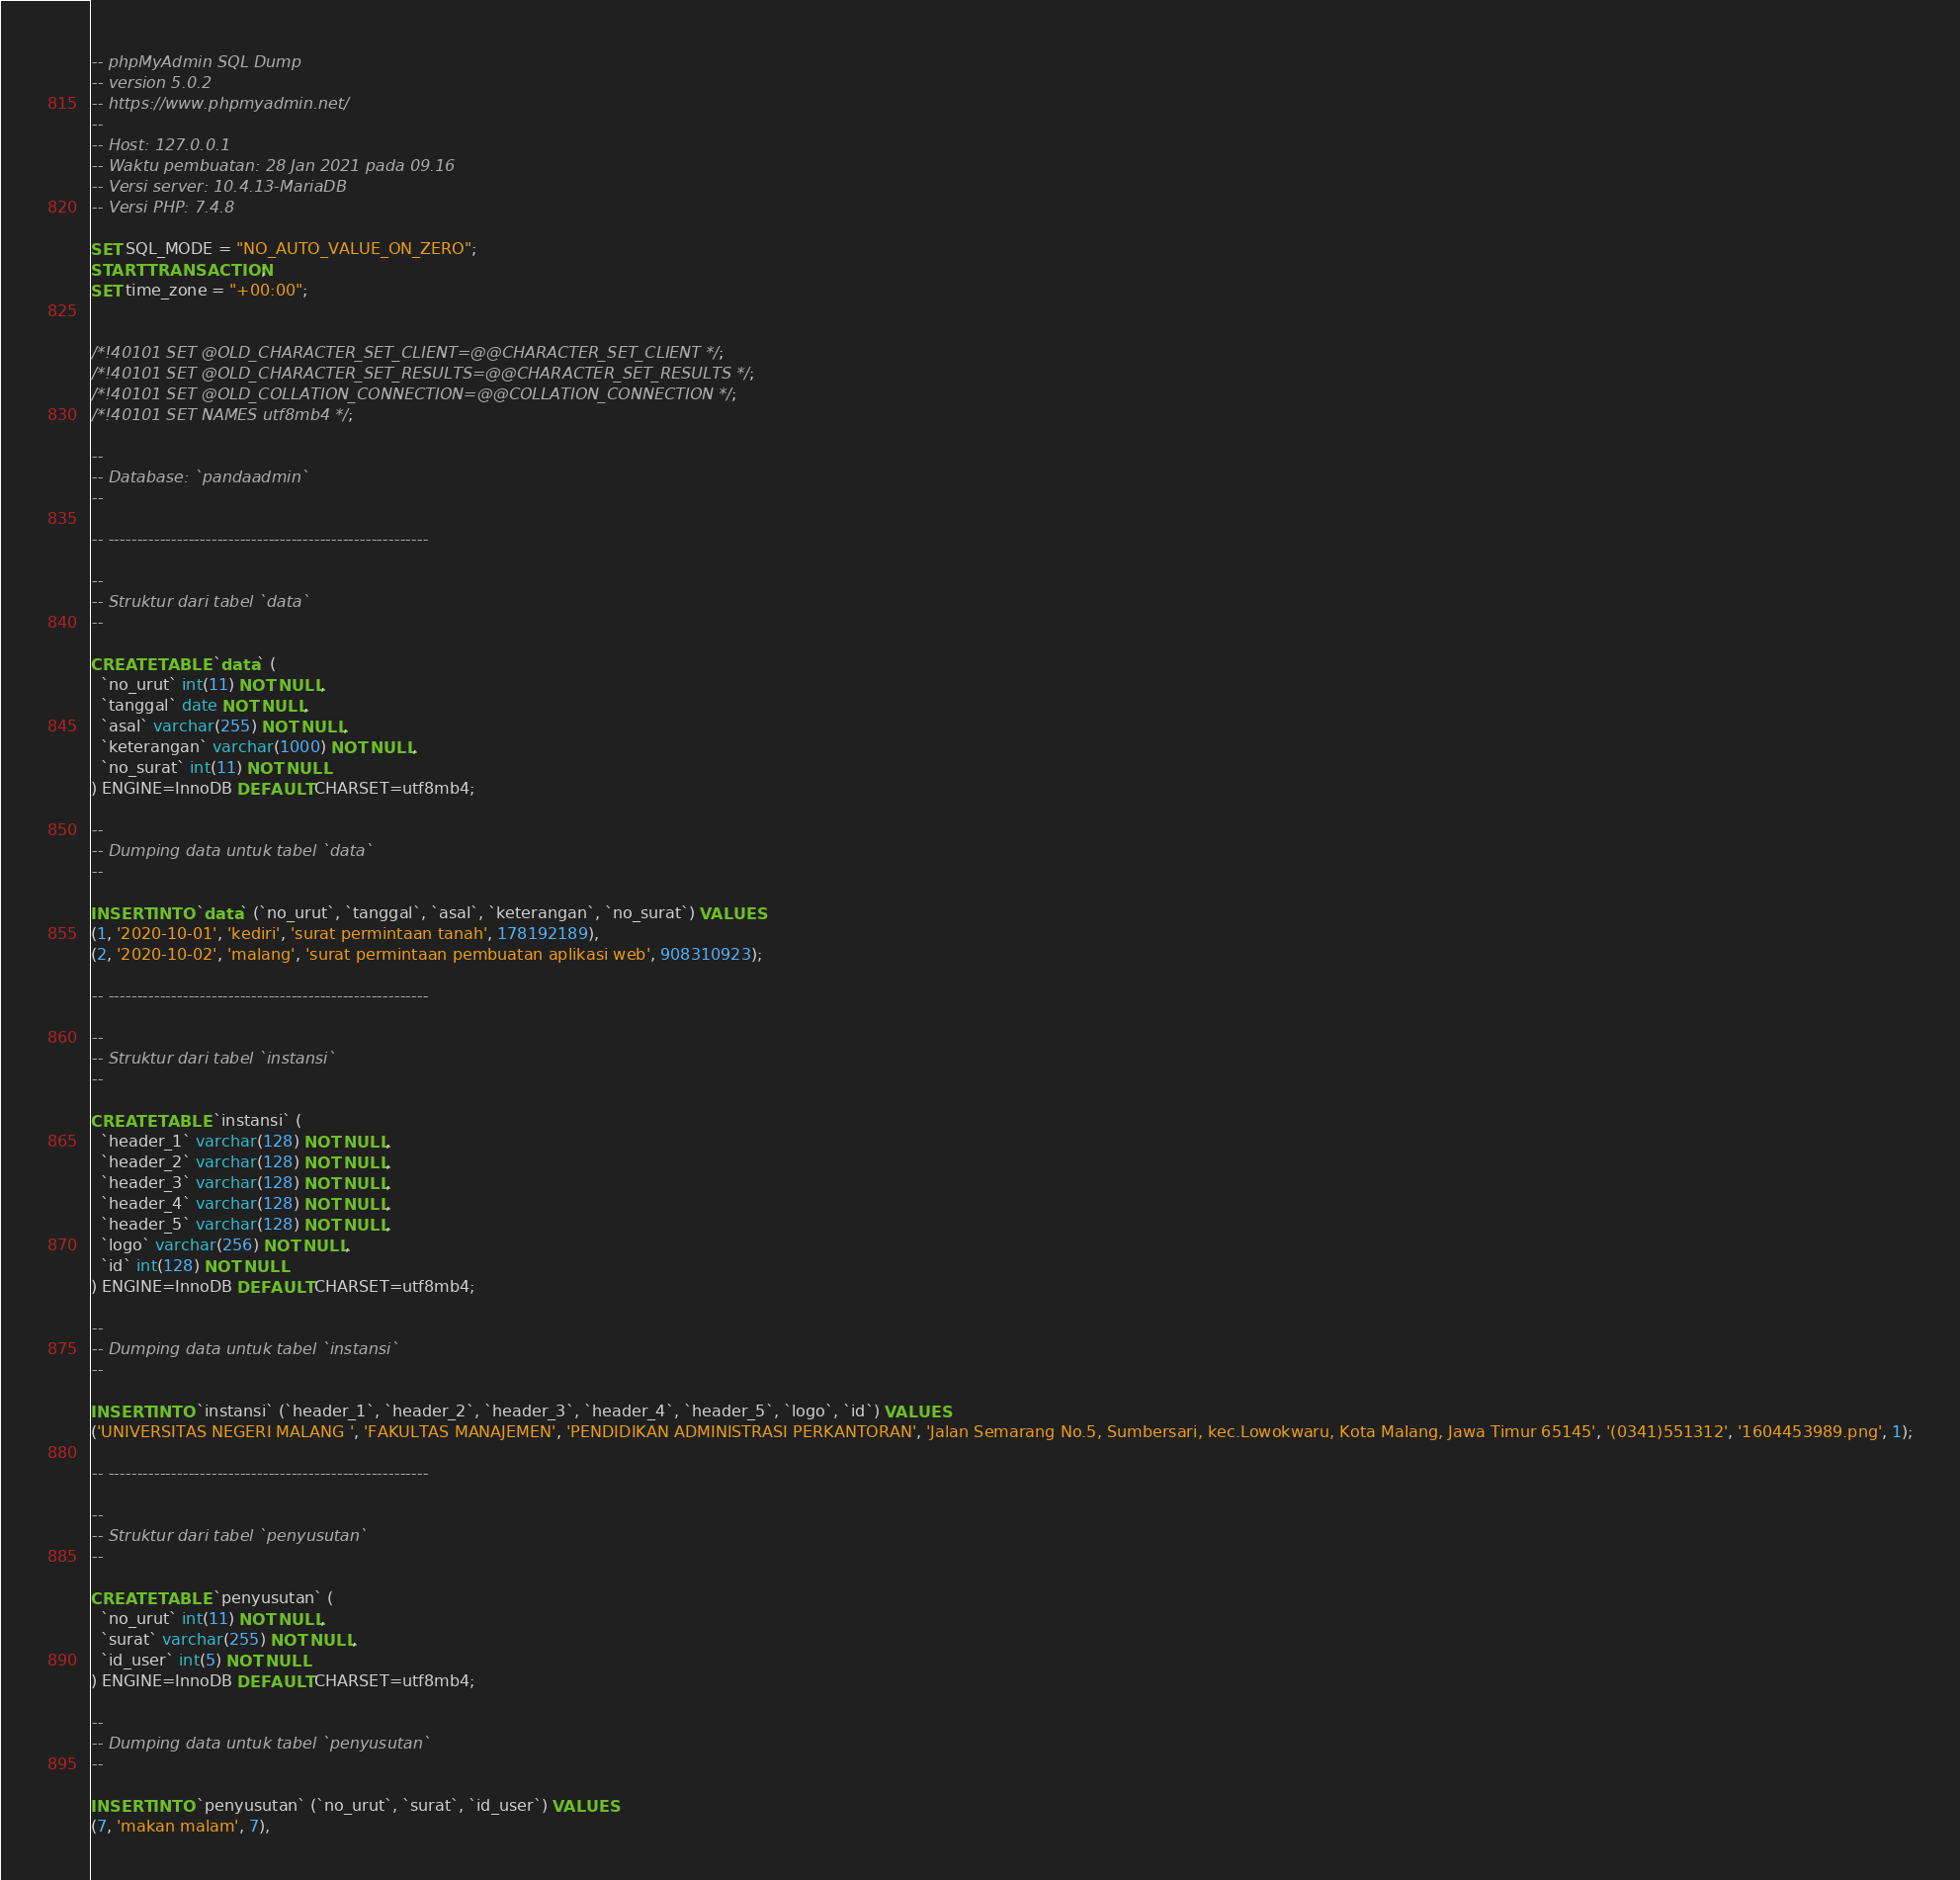<code> <loc_0><loc_0><loc_500><loc_500><_SQL_>-- phpMyAdmin SQL Dump
-- version 5.0.2
-- https://www.phpmyadmin.net/
--
-- Host: 127.0.0.1
-- Waktu pembuatan: 28 Jan 2021 pada 09.16
-- Versi server: 10.4.13-MariaDB
-- Versi PHP: 7.4.8

SET SQL_MODE = "NO_AUTO_VALUE_ON_ZERO";
START TRANSACTION;
SET time_zone = "+00:00";


/*!40101 SET @OLD_CHARACTER_SET_CLIENT=@@CHARACTER_SET_CLIENT */;
/*!40101 SET @OLD_CHARACTER_SET_RESULTS=@@CHARACTER_SET_RESULTS */;
/*!40101 SET @OLD_COLLATION_CONNECTION=@@COLLATION_CONNECTION */;
/*!40101 SET NAMES utf8mb4 */;

--
-- Database: `pandaadmin`
--

-- --------------------------------------------------------

--
-- Struktur dari tabel `data`
--

CREATE TABLE `data` (
  `no_urut` int(11) NOT NULL,
  `tanggal` date NOT NULL,
  `asal` varchar(255) NOT NULL,
  `keterangan` varchar(1000) NOT NULL,
  `no_surat` int(11) NOT NULL
) ENGINE=InnoDB DEFAULT CHARSET=utf8mb4;

--
-- Dumping data untuk tabel `data`
--

INSERT INTO `data` (`no_urut`, `tanggal`, `asal`, `keterangan`, `no_surat`) VALUES
(1, '2020-10-01', 'kediri', 'surat permintaan tanah', 178192189),
(2, '2020-10-02', 'malang', 'surat permintaan pembuatan aplikasi web', 908310923);

-- --------------------------------------------------------

--
-- Struktur dari tabel `instansi`
--

CREATE TABLE `instansi` (
  `header_1` varchar(128) NOT NULL,
  `header_2` varchar(128) NOT NULL,
  `header_3` varchar(128) NOT NULL,
  `header_4` varchar(128) NOT NULL,
  `header_5` varchar(128) NOT NULL,
  `logo` varchar(256) NOT NULL,
  `id` int(128) NOT NULL
) ENGINE=InnoDB DEFAULT CHARSET=utf8mb4;

--
-- Dumping data untuk tabel `instansi`
--

INSERT INTO `instansi` (`header_1`, `header_2`, `header_3`, `header_4`, `header_5`, `logo`, `id`) VALUES
('UNIVERSITAS NEGERI MALANG ', 'FAKULTAS MANAJEMEN', 'PENDIDIKAN ADMINISTRASI PERKANTORAN', 'Jalan Semarang No.5, Sumbersari, kec.Lowokwaru, Kota Malang, Jawa Timur 65145', '(0341)551312', '1604453989.png', 1);

-- --------------------------------------------------------

--
-- Struktur dari tabel `penyusutan`
--

CREATE TABLE `penyusutan` (
  `no_urut` int(11) NOT NULL,
  `surat` varchar(255) NOT NULL,
  `id_user` int(5) NOT NULL
) ENGINE=InnoDB DEFAULT CHARSET=utf8mb4;

--
-- Dumping data untuk tabel `penyusutan`
--

INSERT INTO `penyusutan` (`no_urut`, `surat`, `id_user`) VALUES
(7, 'makan malam', 7),</code> 